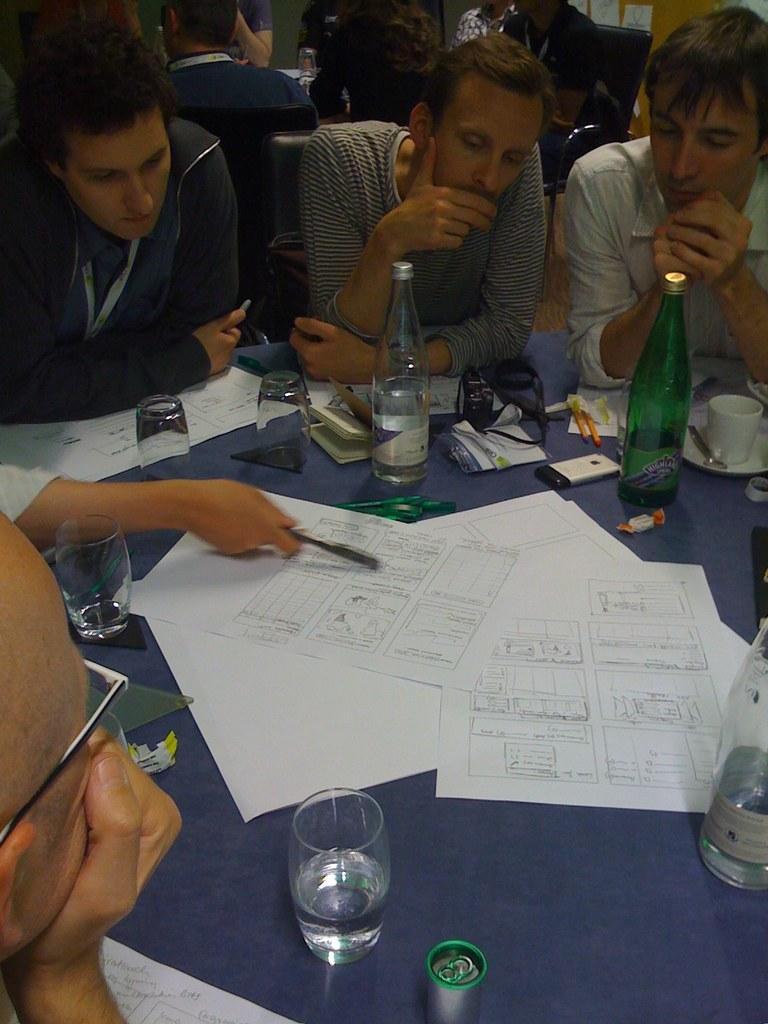Describe this image in one or two sentences. There are many people sitting around a table in their chairs on which some papers, mobiles, bottles, glasses were placed. In the background there are some people sitting here. 